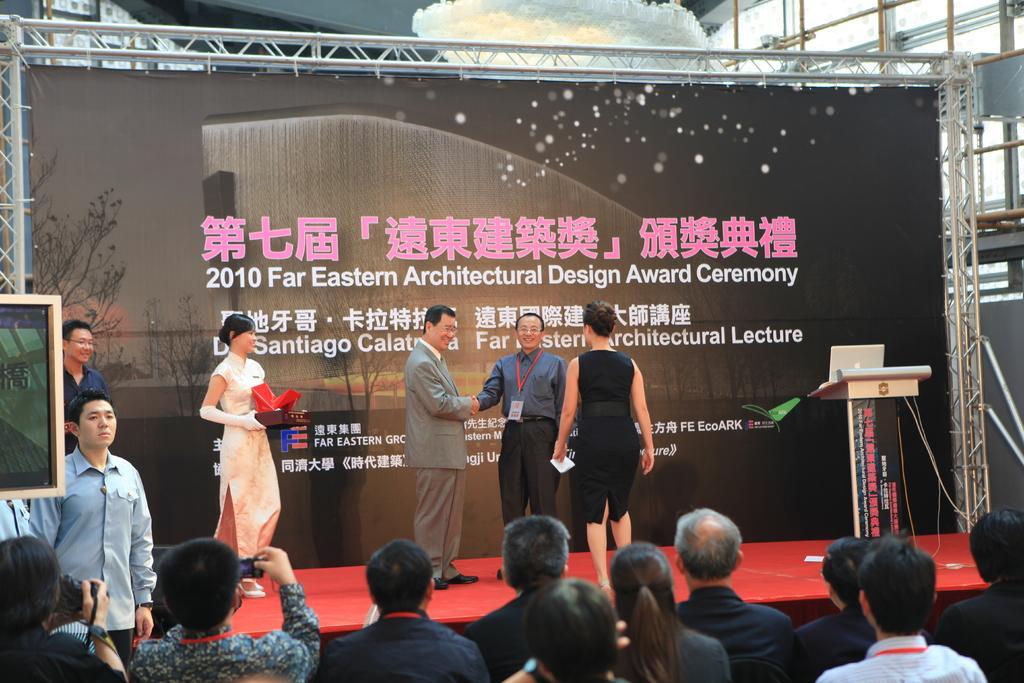Can you describe this image briefly? In this image I can see there are few persons standing on the day-ace and I can see podium and a woman holding a red color object and at the bottom I can see persons and I can see hoarding board in the middle. 